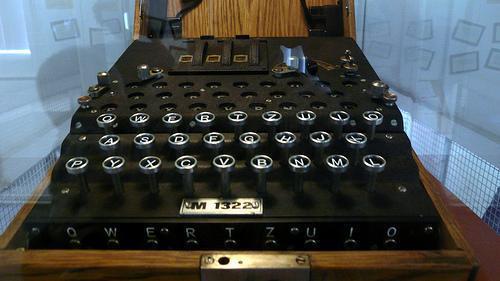How many machines are there?
Give a very brief answer. 1. 